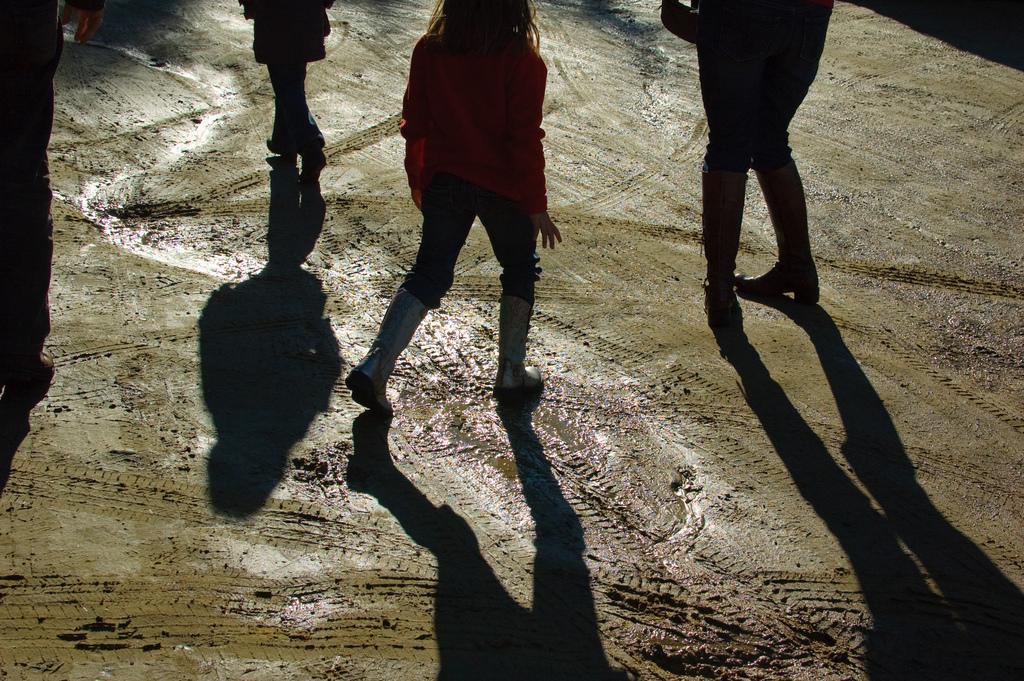Can you describe this image briefly? In this image we can see a few people and also we can see the shadows of those people on the ground. 